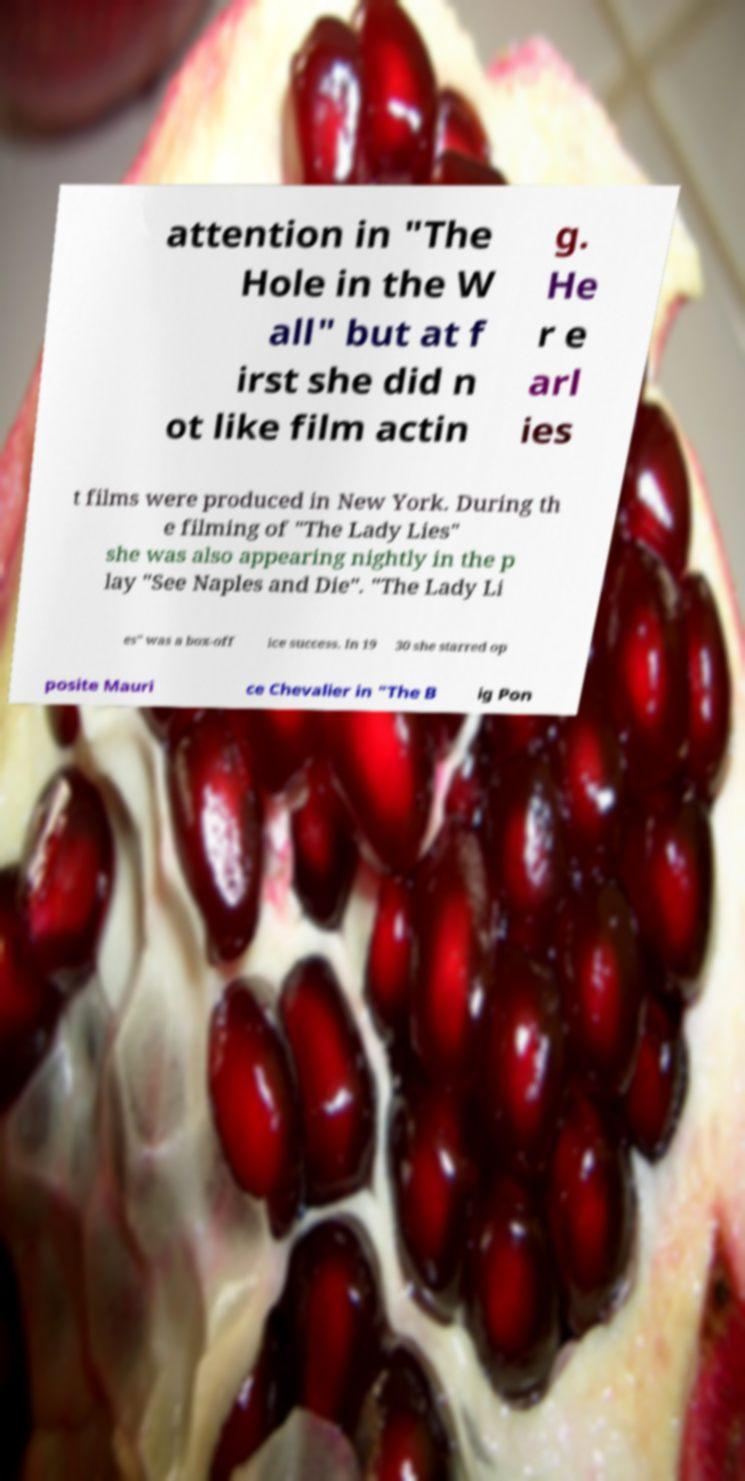I need the written content from this picture converted into text. Can you do that? attention in "The Hole in the W all" but at f irst she did n ot like film actin g. He r e arl ies t films were produced in New York. During th e filming of "The Lady Lies" she was also appearing nightly in the p lay "See Naples and Die". "The Lady Li es" was a box-off ice success. In 19 30 she starred op posite Mauri ce Chevalier in "The B ig Pon 